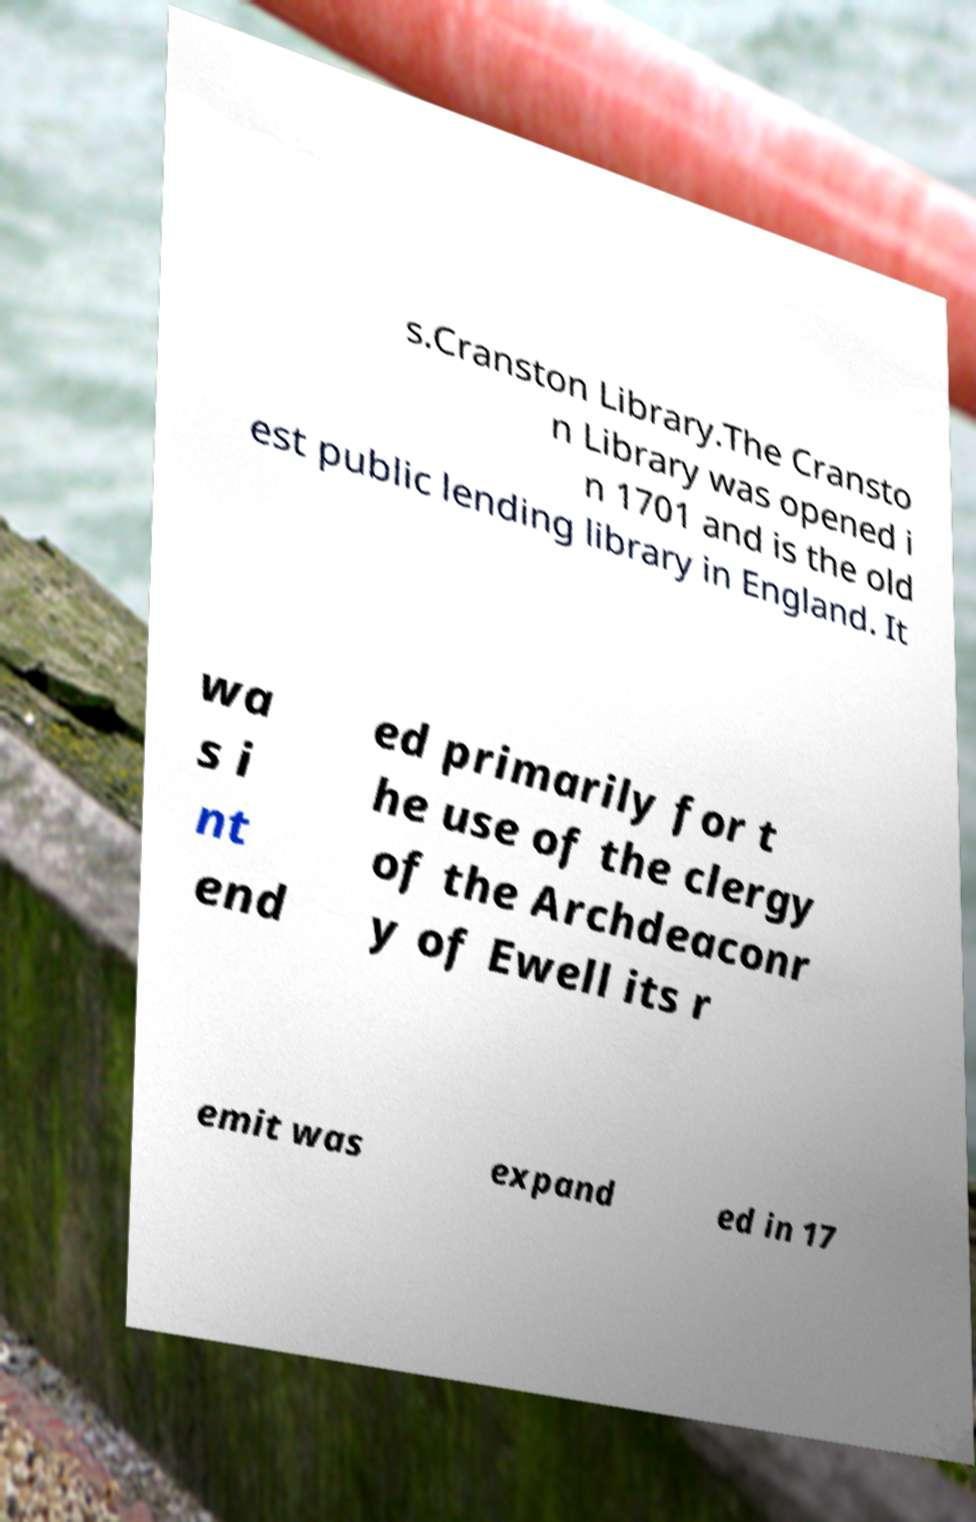Please identify and transcribe the text found in this image. s.Cranston Library.The Cransto n Library was opened i n 1701 and is the old est public lending library in England. It wa s i nt end ed primarily for t he use of the clergy of the Archdeaconr y of Ewell its r emit was expand ed in 17 